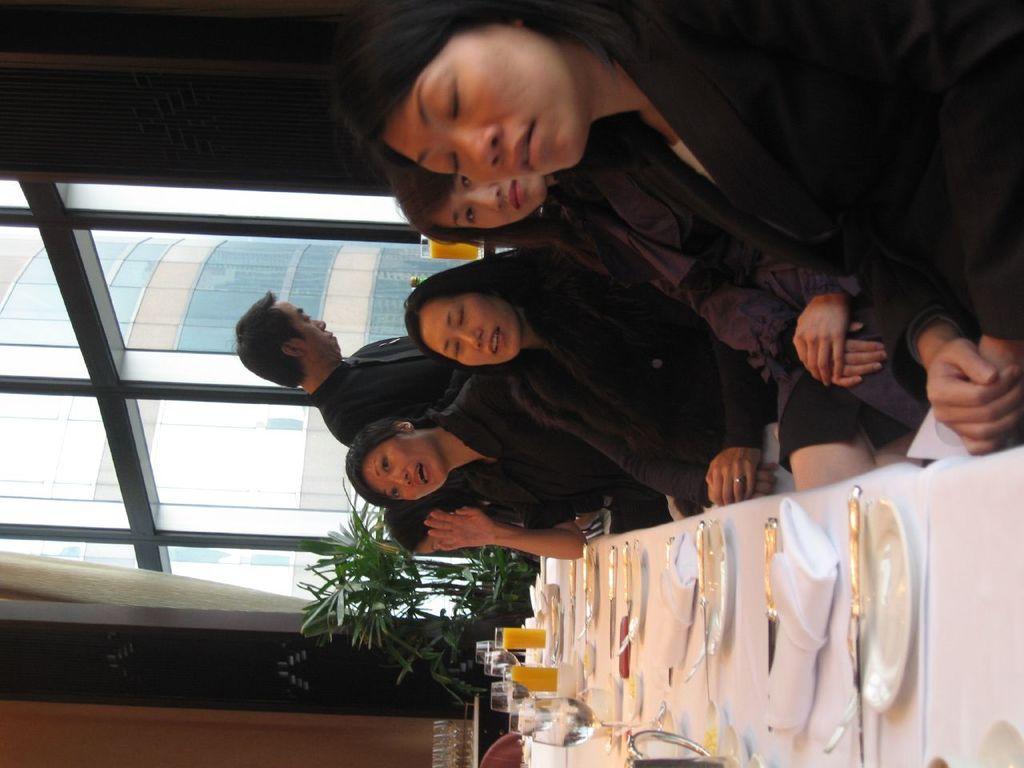Can you describe this image briefly? Here we can see few persons are sitting on the chairs and there is a man standing on the floor. Here we can see a table. On the table there are plates, glasses, knives, and tissue papers. There are plants. In the background we can see a glass. From the glass we can see a building. 